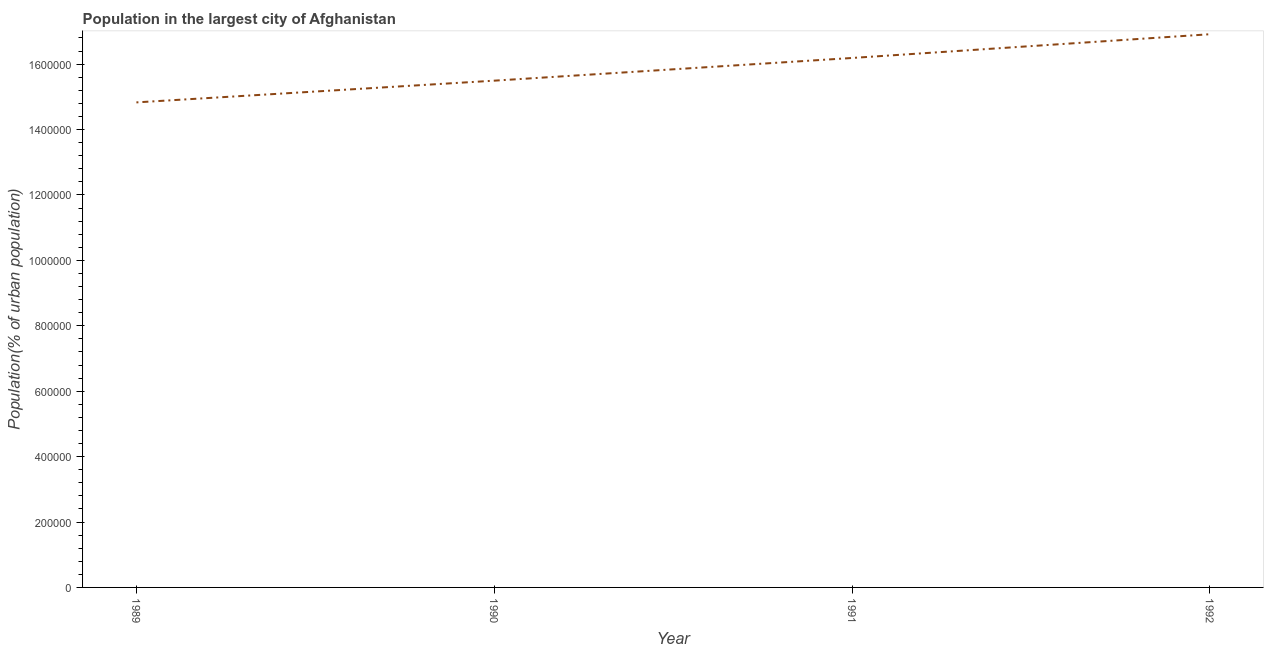What is the population in largest city in 1992?
Offer a terse response. 1.69e+06. Across all years, what is the maximum population in largest city?
Offer a terse response. 1.69e+06. Across all years, what is the minimum population in largest city?
Make the answer very short. 1.48e+06. In which year was the population in largest city maximum?
Ensure brevity in your answer.  1992. What is the sum of the population in largest city?
Offer a terse response. 6.34e+06. What is the difference between the population in largest city in 1990 and 1991?
Your response must be concise. -6.94e+04. What is the average population in largest city per year?
Offer a terse response. 1.59e+06. What is the median population in largest city?
Offer a very short reply. 1.58e+06. In how many years, is the population in largest city greater than 400000 %?
Provide a short and direct response. 4. Do a majority of the years between 1989 and 1992 (inclusive) have population in largest city greater than 1000000 %?
Your answer should be compact. Yes. What is the ratio of the population in largest city in 1989 to that in 1990?
Offer a very short reply. 0.96. Is the population in largest city in 1990 less than that in 1991?
Provide a short and direct response. Yes. Is the difference between the population in largest city in 1990 and 1991 greater than the difference between any two years?
Ensure brevity in your answer.  No. What is the difference between the highest and the second highest population in largest city?
Offer a terse response. 7.26e+04. What is the difference between the highest and the lowest population in largest city?
Your response must be concise. 2.08e+05. In how many years, is the population in largest city greater than the average population in largest city taken over all years?
Offer a very short reply. 2. Does the population in largest city monotonically increase over the years?
Give a very brief answer. Yes. What is the difference between two consecutive major ticks on the Y-axis?
Keep it short and to the point. 2.00e+05. Are the values on the major ticks of Y-axis written in scientific E-notation?
Keep it short and to the point. No. Does the graph contain grids?
Provide a succinct answer. No. What is the title of the graph?
Offer a terse response. Population in the largest city of Afghanistan. What is the label or title of the X-axis?
Ensure brevity in your answer.  Year. What is the label or title of the Y-axis?
Offer a very short reply. Population(% of urban population). What is the Population(% of urban population) in 1989?
Make the answer very short. 1.48e+06. What is the Population(% of urban population) in 1990?
Provide a succinct answer. 1.55e+06. What is the Population(% of urban population) of 1991?
Provide a succinct answer. 1.62e+06. What is the Population(% of urban population) of 1992?
Make the answer very short. 1.69e+06. What is the difference between the Population(% of urban population) in 1989 and 1990?
Keep it short and to the point. -6.64e+04. What is the difference between the Population(% of urban population) in 1989 and 1991?
Provide a succinct answer. -1.36e+05. What is the difference between the Population(% of urban population) in 1989 and 1992?
Keep it short and to the point. -2.08e+05. What is the difference between the Population(% of urban population) in 1990 and 1991?
Ensure brevity in your answer.  -6.94e+04. What is the difference between the Population(% of urban population) in 1990 and 1992?
Give a very brief answer. -1.42e+05. What is the difference between the Population(% of urban population) in 1991 and 1992?
Your response must be concise. -7.26e+04. What is the ratio of the Population(% of urban population) in 1989 to that in 1991?
Keep it short and to the point. 0.92. What is the ratio of the Population(% of urban population) in 1989 to that in 1992?
Your answer should be very brief. 0.88. What is the ratio of the Population(% of urban population) in 1990 to that in 1992?
Ensure brevity in your answer.  0.92. What is the ratio of the Population(% of urban population) in 1991 to that in 1992?
Give a very brief answer. 0.96. 